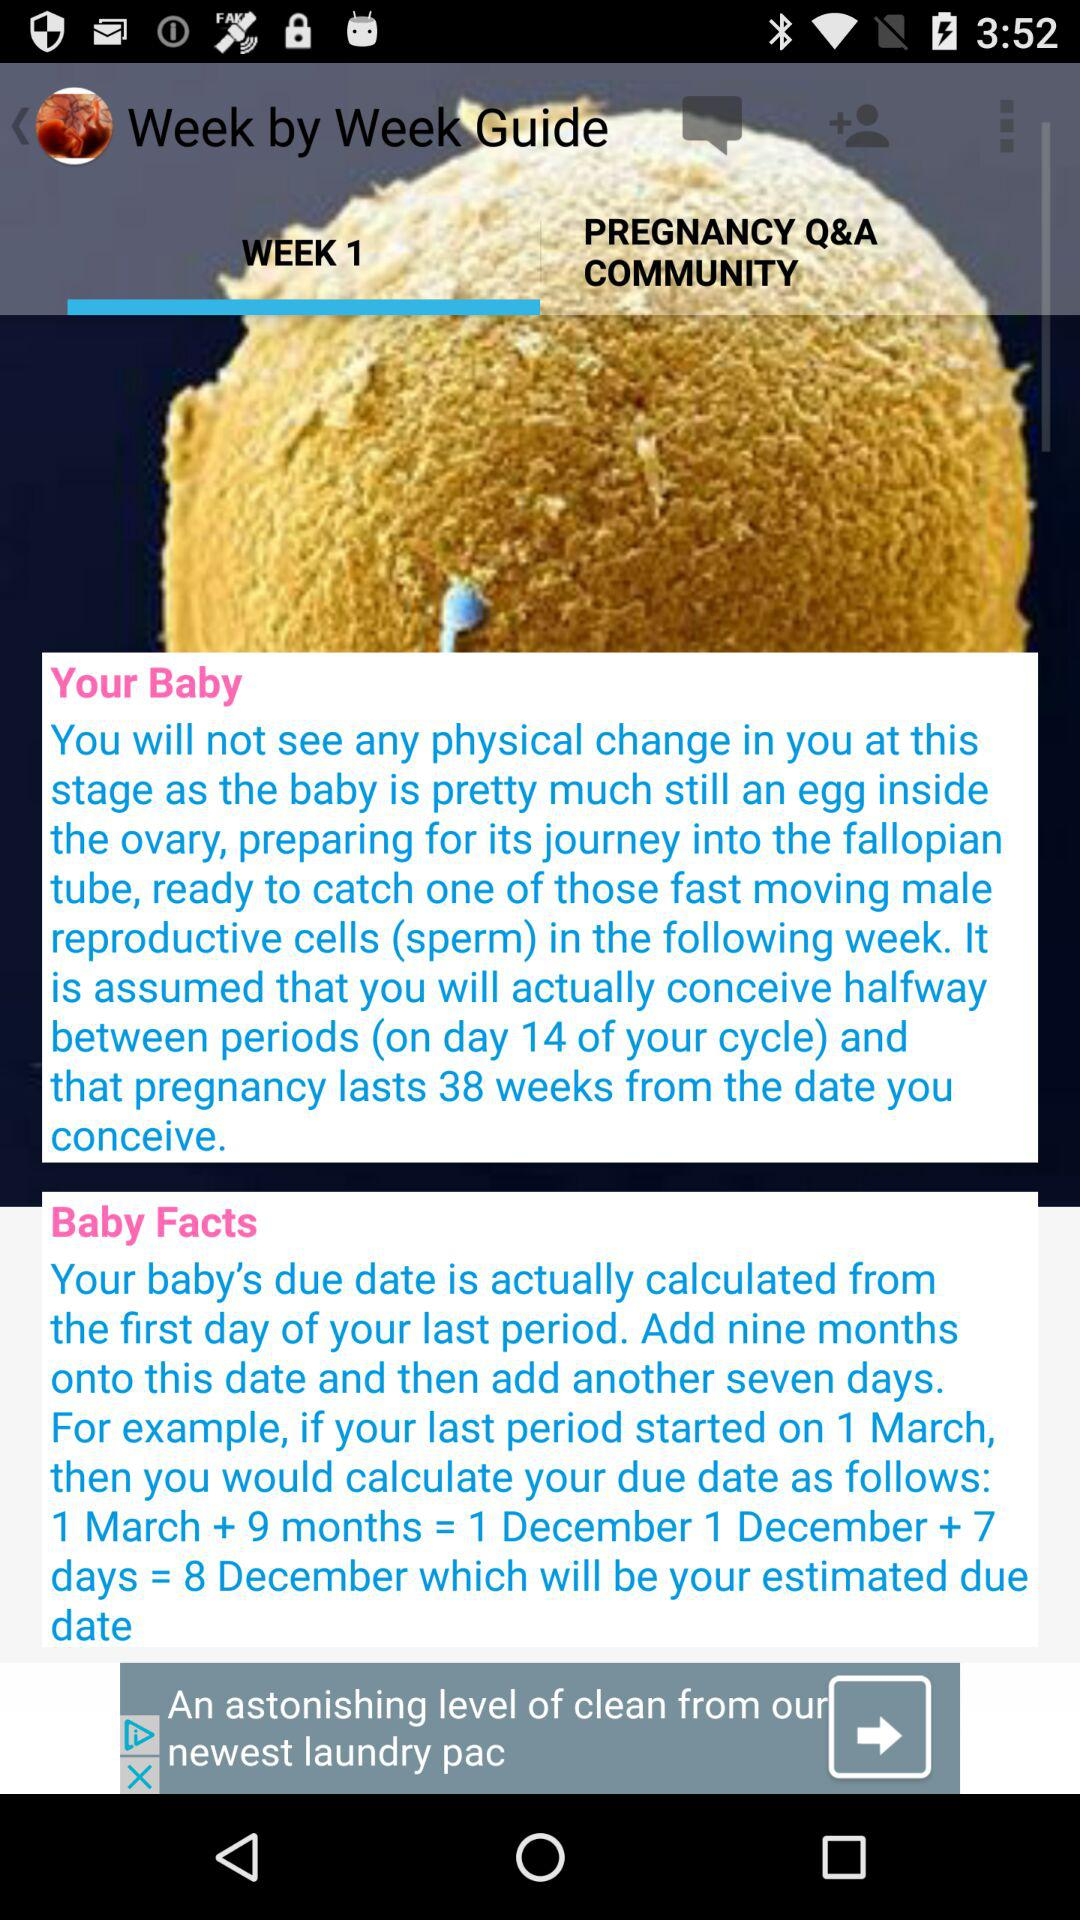When is the baby's due date calculated? The baby's due date is calculated from the first day of your last period. 